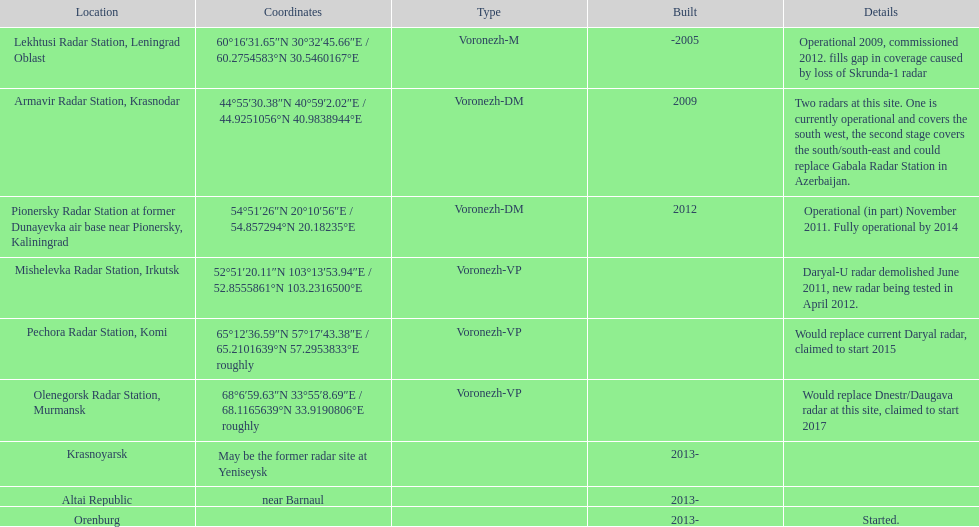Would you be able to parse every entry in this table? {'header': ['Location', 'Coordinates', 'Type', 'Built', 'Details'], 'rows': [['Lekhtusi Radar Station, Leningrad Oblast', '60°16′31.65″N 30°32′45.66″E\ufeff / \ufeff60.2754583°N 30.5460167°E', 'Voronezh-M', '-2005', 'Operational 2009, commissioned 2012. fills gap in coverage caused by loss of Skrunda-1 radar'], ['Armavir Radar Station, Krasnodar', '44°55′30.38″N 40°59′2.02″E\ufeff / \ufeff44.9251056°N 40.9838944°E', 'Voronezh-DM', '2009', 'Two radars at this site. One is currently operational and covers the south west, the second stage covers the south/south-east and could replace Gabala Radar Station in Azerbaijan.'], ['Pionersky Radar Station at former Dunayevka air base near Pionersky, Kaliningrad', '54°51′26″N 20°10′56″E\ufeff / \ufeff54.857294°N 20.18235°E', 'Voronezh-DM', '2012', 'Operational (in part) November 2011. Fully operational by 2014'], ['Mishelevka Radar Station, Irkutsk', '52°51′20.11″N 103°13′53.94″E\ufeff / \ufeff52.8555861°N 103.2316500°E', 'Voronezh-VP', '', 'Daryal-U radar demolished June 2011, new radar being tested in April 2012.'], ['Pechora Radar Station, Komi', '65°12′36.59″N 57°17′43.38″E\ufeff / \ufeff65.2101639°N 57.2953833°E roughly', 'Voronezh-VP', '', 'Would replace current Daryal radar, claimed to start 2015'], ['Olenegorsk Radar Station, Murmansk', '68°6′59.63″N 33°55′8.69″E\ufeff / \ufeff68.1165639°N 33.9190806°E roughly', 'Voronezh-VP', '', 'Would replace Dnestr/Daugava radar at this site, claimed to start 2017'], ['Krasnoyarsk', 'May be the former radar site at Yeniseysk', '', '2013-', ''], ['Altai Republic', 'near Barnaul', '', '2013-', ''], ['Orenburg', '', '', '2013-', 'Started.']]} What is the only radar that will start in 2015? Pechora Radar Station, Komi. 